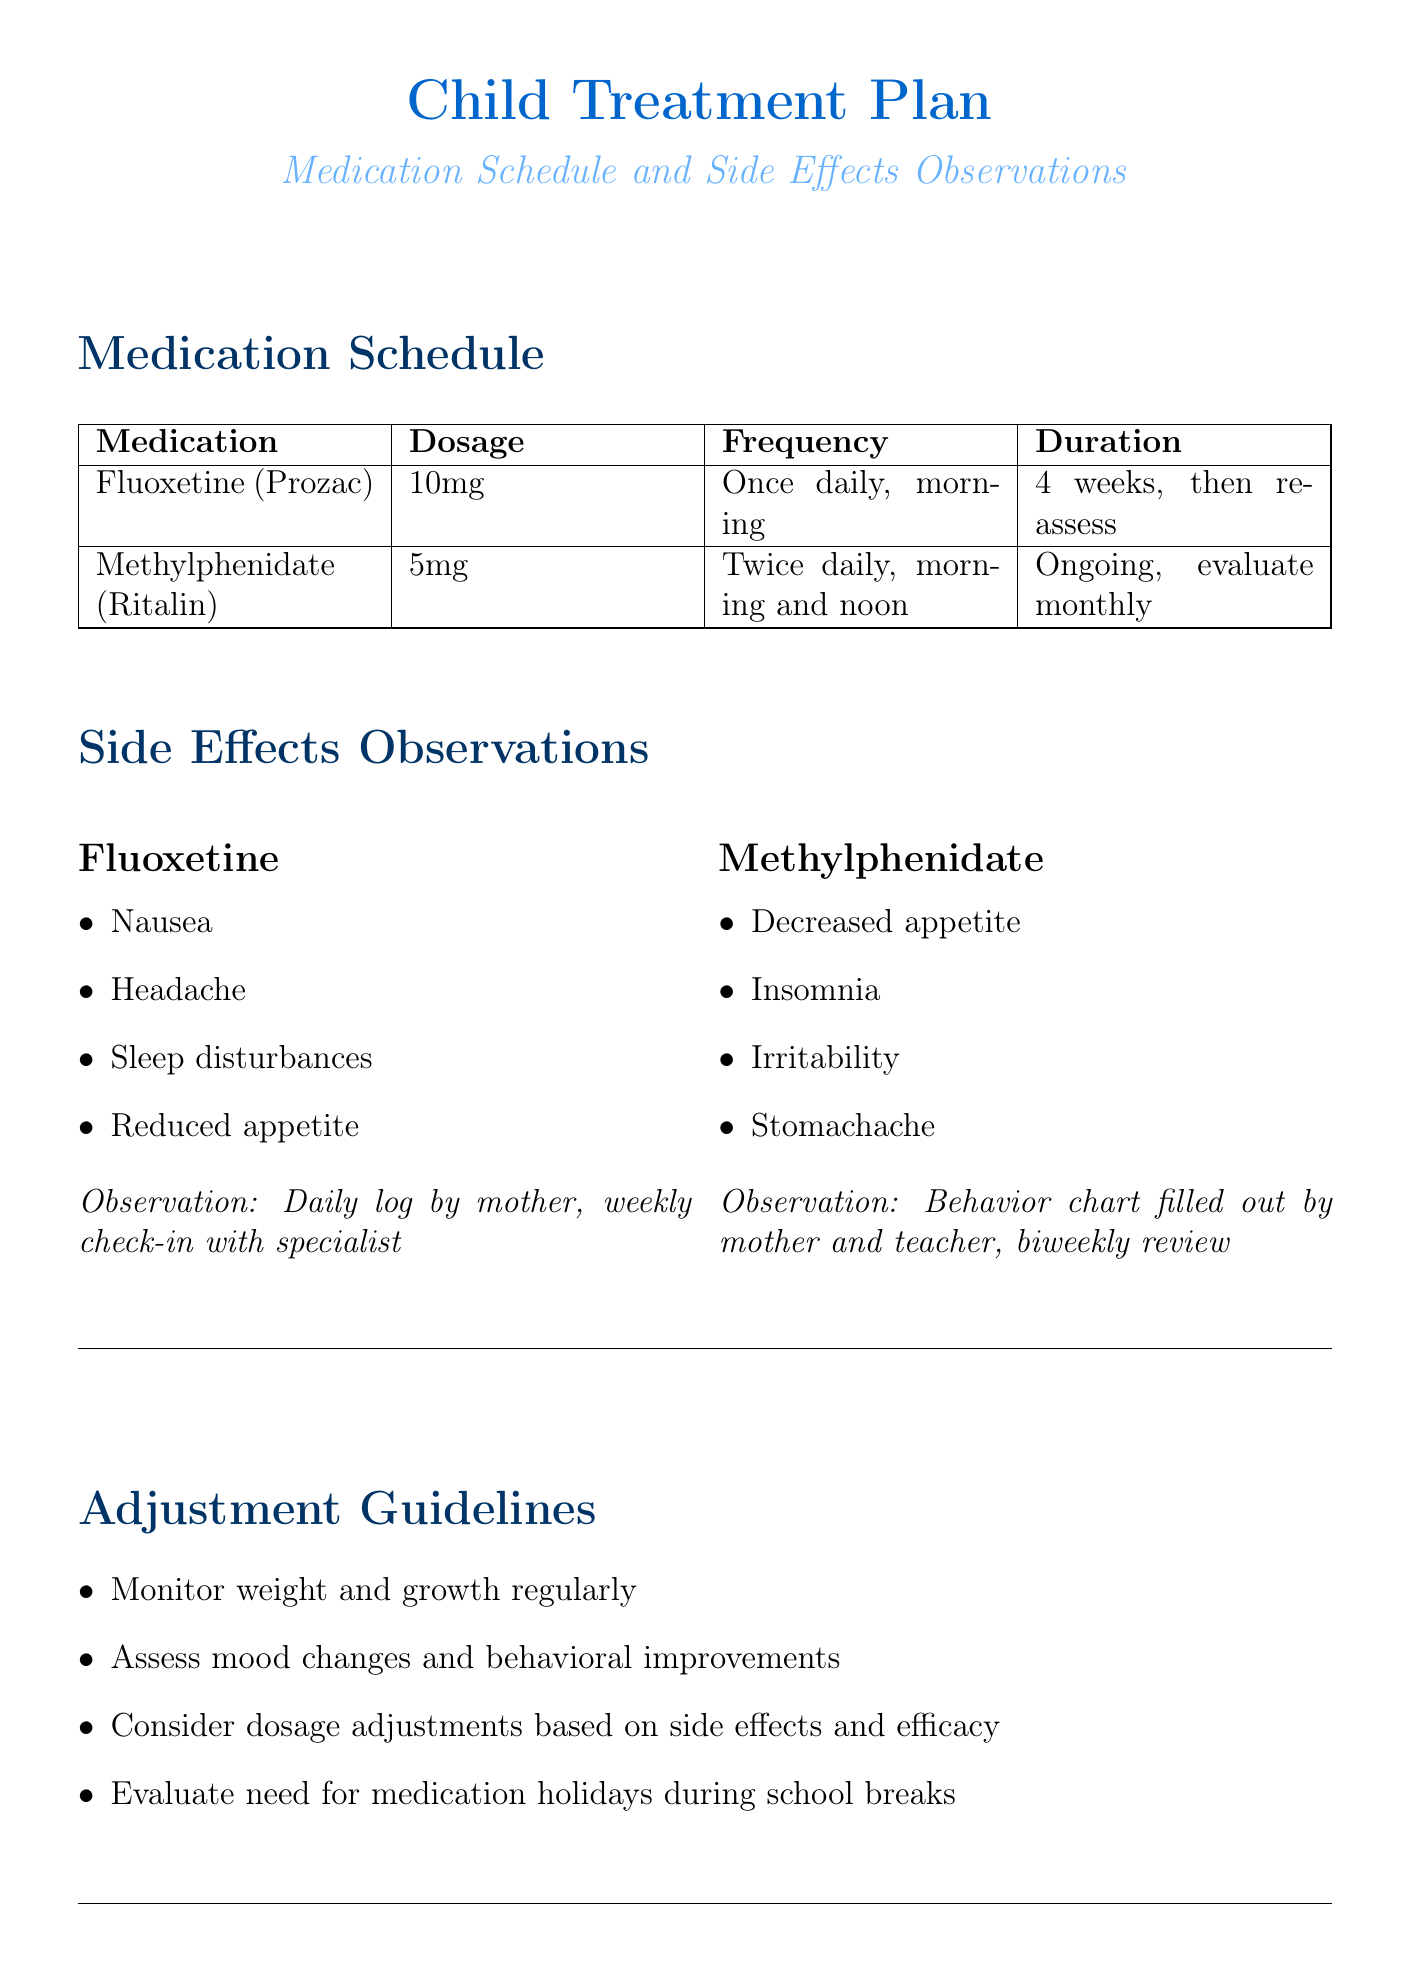What medication is prescribed for the child? The document lists Fluoxetine (Prozac) and Methylphenidate (Ritalin) as the prescribed medications.
Answer: Fluoxetine (Prozac), Methylphenidate (Ritalin) What is the frequency of Fluoxetine intake? Fluoxetine is prescribed to be taken once daily in the morning.
Answer: Once daily, morning How long is the duration for the Fluoxetine treatment before reassessment? The duration for Fluoxetine is specified as 4 weeks, then reassess.
Answer: 4 weeks, then reassess What are the possible side effects of Methylphenidate? The possible side effects include decreased appetite, insomnia, irritability, and stomachache.
Answer: Decreased appetite, insomnia, irritability, stomachache What observation method is used for tracking Fluoxetine side effects? The observation method for Fluoxetine side effects is a daily log by the mother and a weekly check-in with the specialist.
Answer: Daily log by mother, weekly check-in with specialist How often are behavioral assessments for Methylphenidate conducted? Behavioral assessments for Methylphenidate are conducted biweekly.
Answer: Biweekly What supportive therapy is mentioned for appetite changes? Nutritional guidance is mentioned to address potential appetite changes.
Answer: Nutritional guidance Who is the emergency contact for child psychiatric care? The document lists Dr. Sarah Johnson as the emergency contact for child psychiatric care.
Answer: Dr. Sarah Johnson How often should the medication schedule be evaluated for Methylphenidate? The medication schedule for Methylphenidate is to be evaluated monthly.
Answer: Monthly 